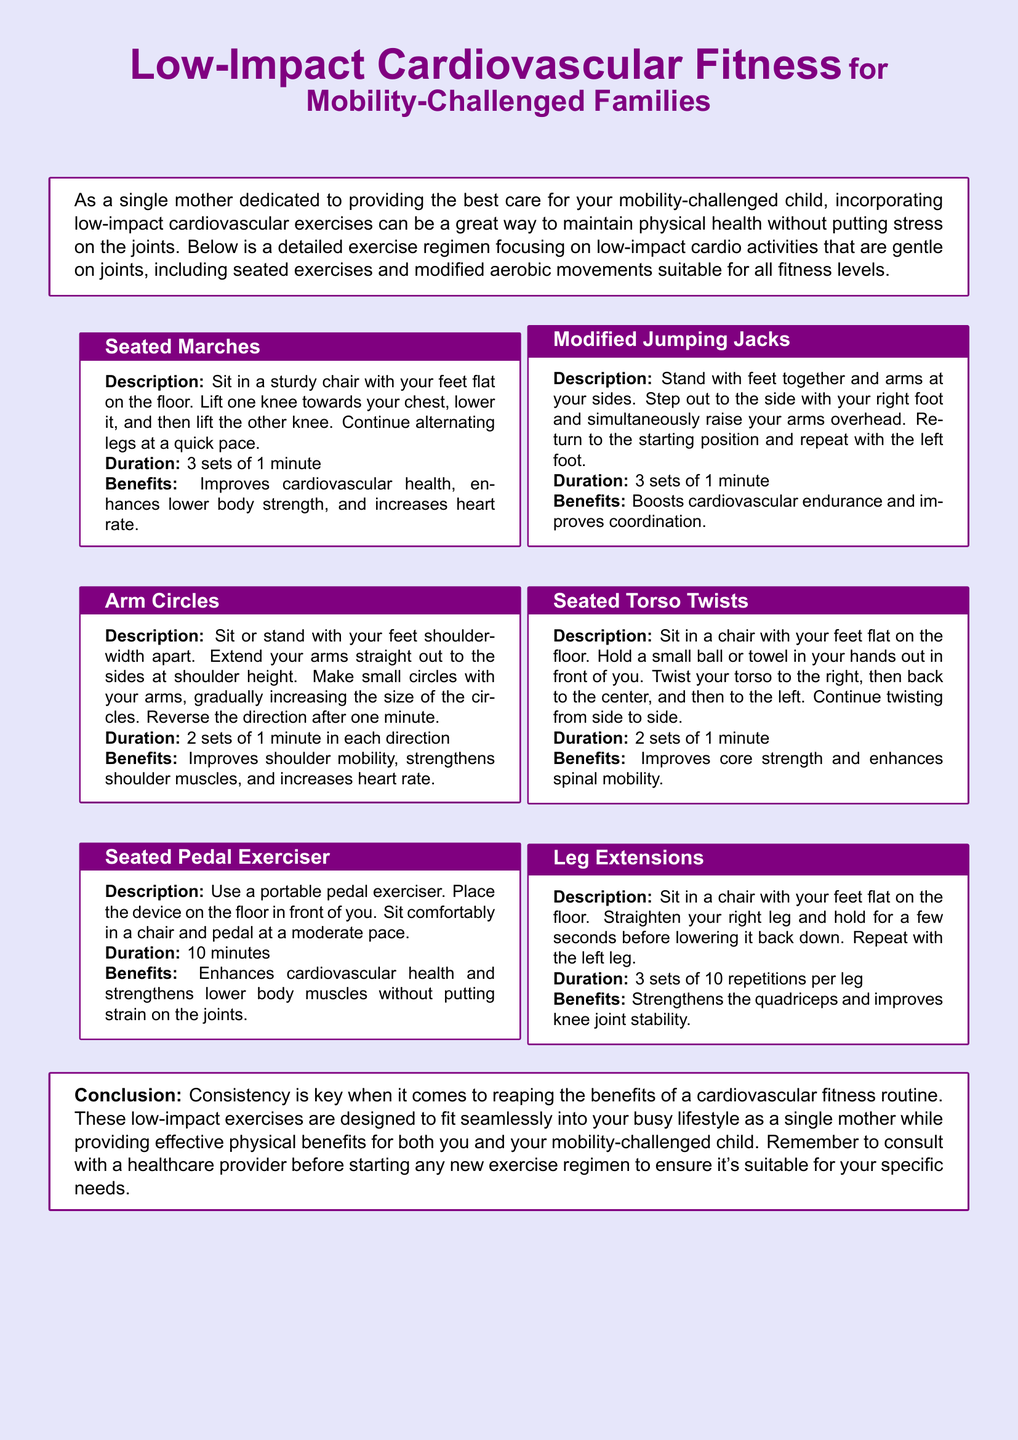What is the main focus of the document? The document focuses on low-impact cardiovascular exercises suitable for mobility-challenged families.
Answer: low-impact cardiovascular exercises What activity involves lifting knees in a seated position? The description of this activity is found under "Seated Marches," which involves lifting one knee towards your chest while seated.
Answer: Seated Marches How long should the seated pedal exerciser be used? The duration for using the seated pedal exerciser is mentioned in the corresponding section.
Answer: 10 minutes What benefit is associated with arm circles? The benefits of the arm circles are listed in that section of the document.
Answer: Improves shoulder mobility What type of movement is the "Modified Jumping Jacks"? The description identifies this exercise as a variation of the traditional jumping jacks that accommodates mobility challenges.
Answer: Modified jumping jacks How many sets are recommended for leg extensions? The information regarding the sets can be found in the section on leg extensions.
Answer: 3 sets What is the duration for seated torso twists? The document specifies the duration for this exercise in its description.
Answer: 2 sets of 1 minute What should be done before starting any new exercise regimen? The conclusion of the document advises on a specific action regarding starting new exercises.
Answer: Consult with a healthcare provider 